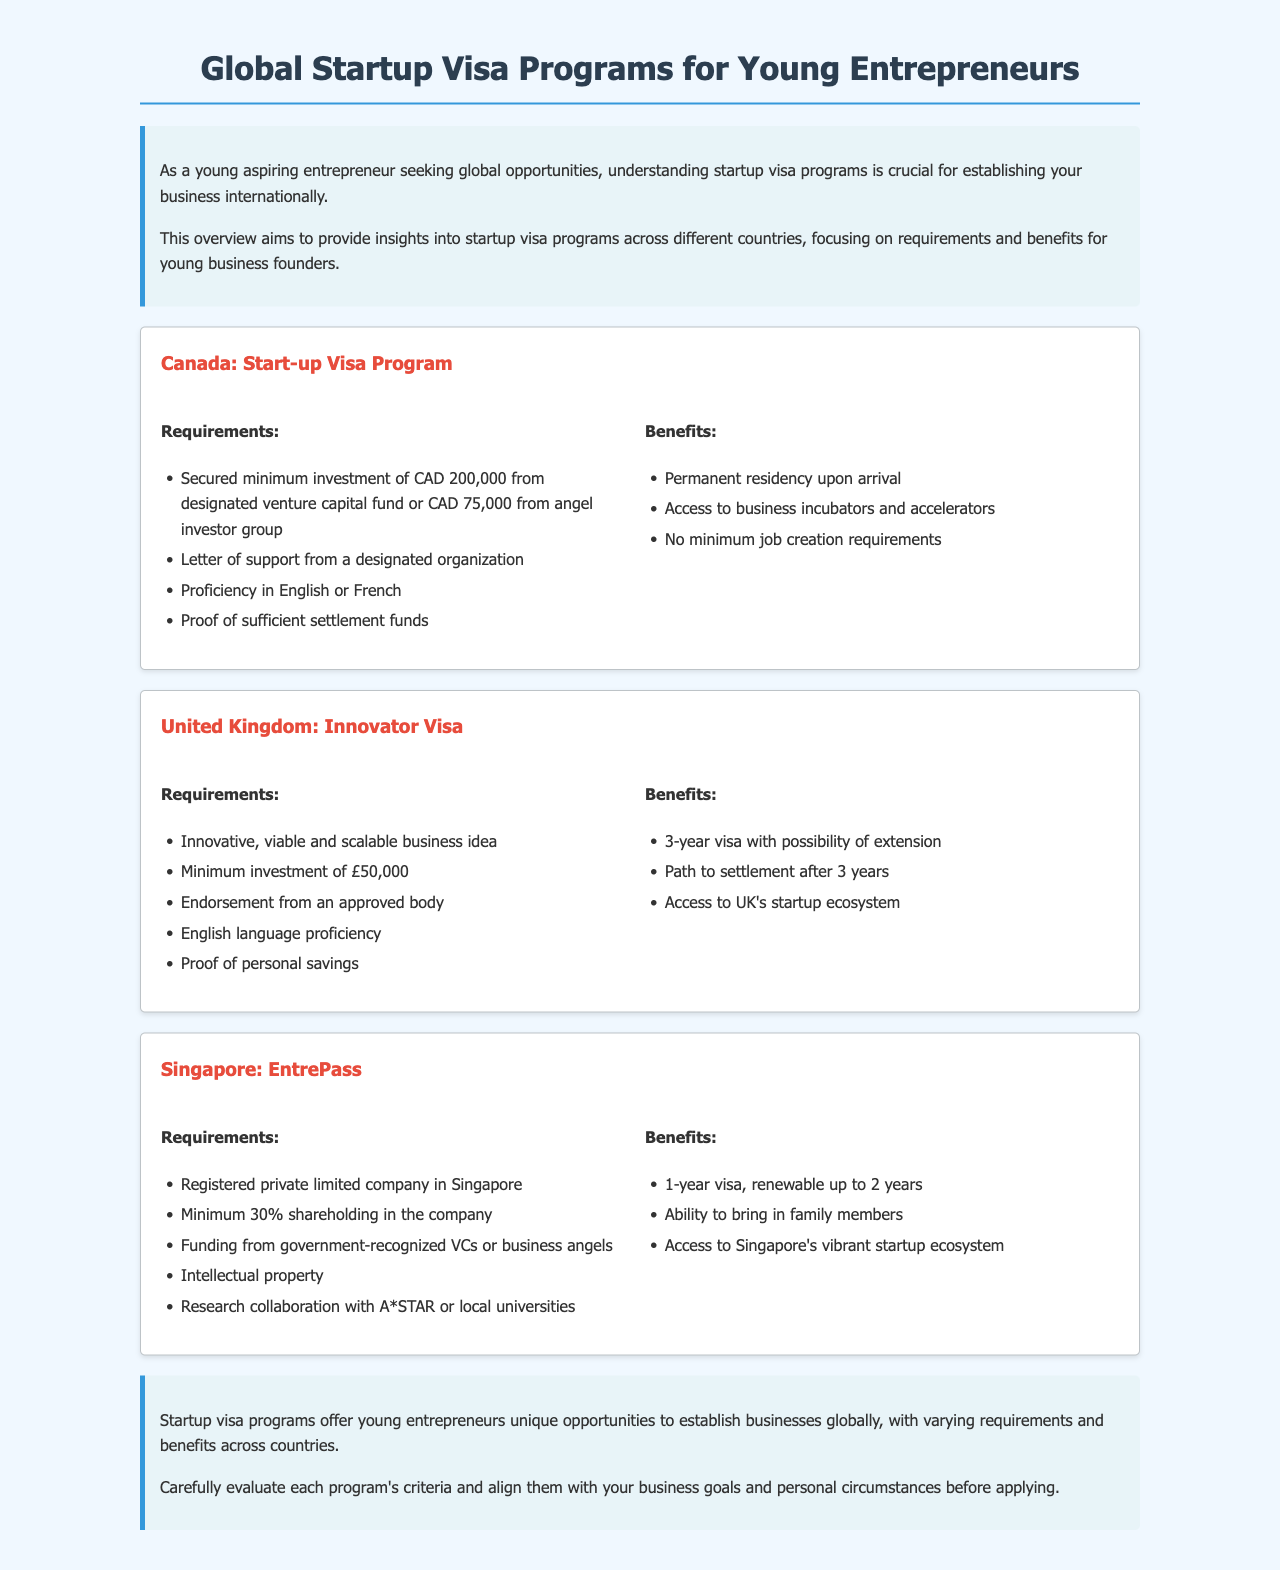What is the minimum investment required for Canada’s Start-up Visa Program? The document states that a minimum investment of CAD 200,000 is required from a designated venture capital fund or CAD 75,000 from an angel investor group.
Answer: CAD 200,000 or CAD 75,000 What is the duration of the Innovator Visa in the United Kingdom? According to the document, the Innovator Visa is valid for a duration of 3 years.
Answer: 3 years What proof is necessary for the Singapore EntrePass regarding company ownership? The document highlights that a minimum of 30% shareholding in the registered company is required as proof.
Answer: 30% What is a required language proficiency for all the mentioned startup visa programs? The requirements indicate that English or French proficiency is needed for the programs in Canada and the UK, while only English is mentioned for the UK.
Answer: English or French Which country offers a path to settlement after 3 years? The document specifies that the United Kingdom provides a path to settlement after 3 years for the Innovator Visa holders.
Answer: United Kingdom What organization needs to provide a letter of support for Canada’s Start-up Visa Program? The document states that this letter must come from a designated organization.
Answer: Designated organization What benefit does the EntrePass in Singapore provide related to family? According to the document, the EntrePass allows the visa holder to bring in family members.
Answer: Bring in family members What type of company registration is required for the EntrePass in Singapore? The document states that a private limited company must be registered in Singapore.
Answer: Registered private limited company 